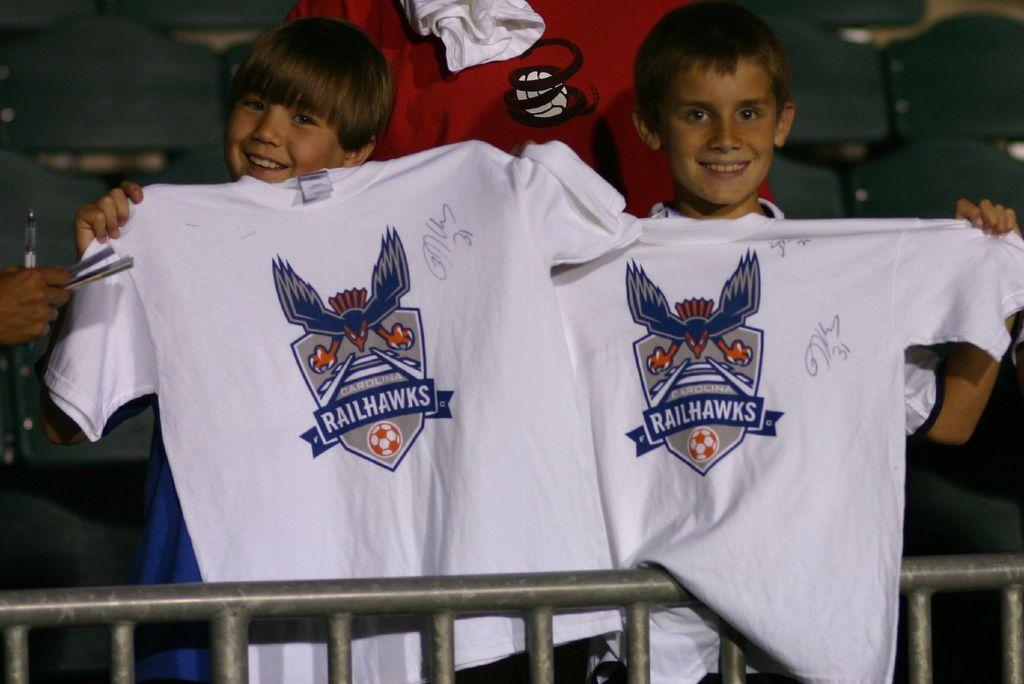Provide a one-sentence caption for the provided image. two young boys holding up t-shirts of the Railhawks. 